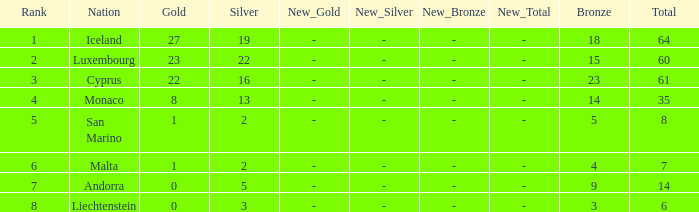How many golds for the nation with 14 total? 0.0. 